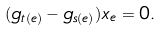<formula> <loc_0><loc_0><loc_500><loc_500>( g _ { t ( e ) } - g _ { s ( e ) } ) x _ { e } = 0 .</formula> 